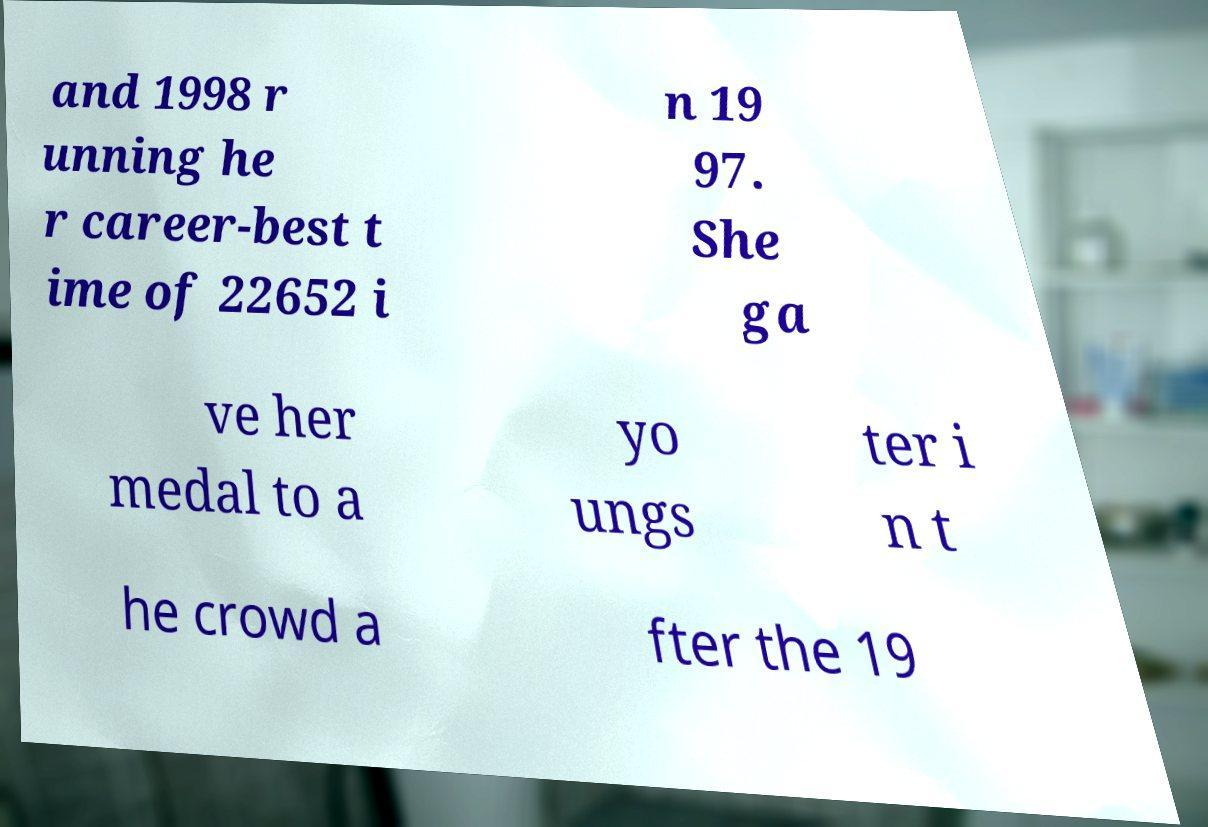Please read and relay the text visible in this image. What does it say? and 1998 r unning he r career-best t ime of 22652 i n 19 97. She ga ve her medal to a yo ungs ter i n t he crowd a fter the 19 